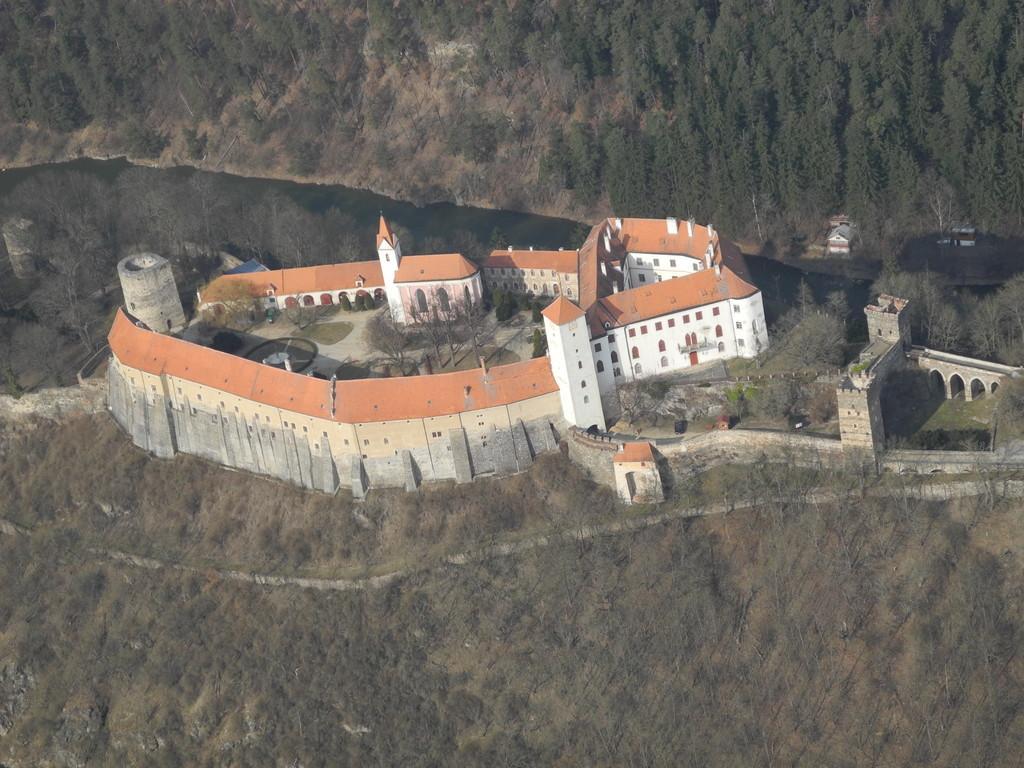Please provide a concise description of this image. This picture is clicked outside the city. In the foreground we can see the green objects seems to be the trees. In the center there is a castle. In the background we can see the trees. 